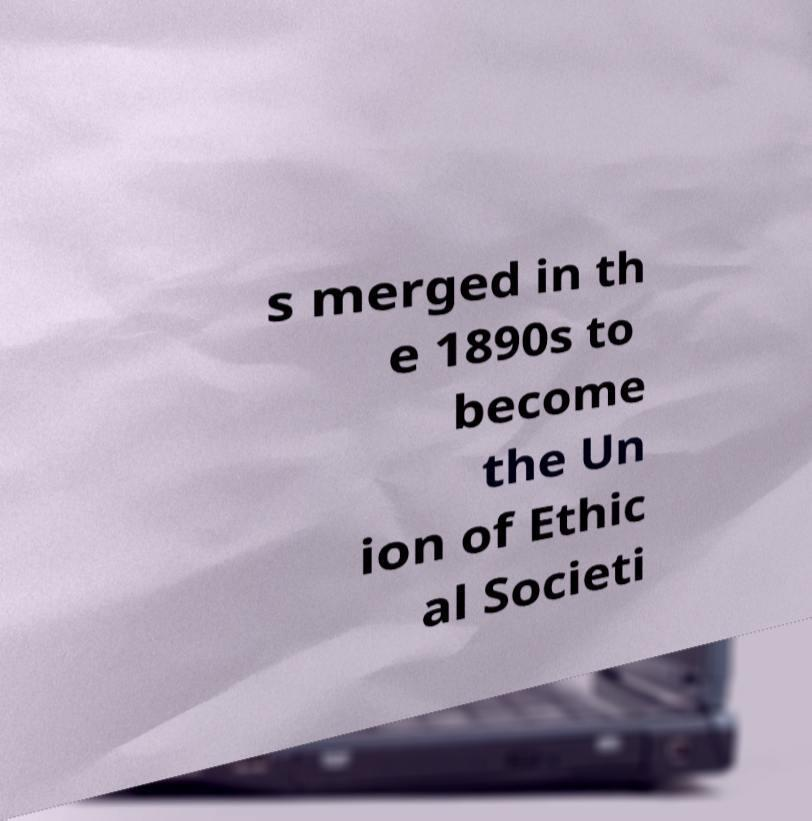Can you accurately transcribe the text from the provided image for me? s merged in th e 1890s to become the Un ion of Ethic al Societi 